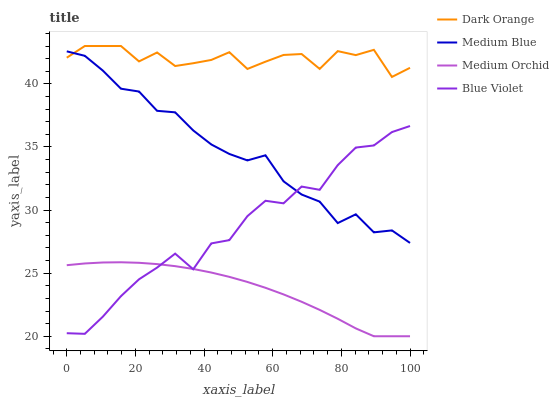Does Medium Blue have the minimum area under the curve?
Answer yes or no. No. Does Medium Blue have the maximum area under the curve?
Answer yes or no. No. Is Medium Blue the smoothest?
Answer yes or no. No. Is Medium Blue the roughest?
Answer yes or no. No. Does Medium Blue have the lowest value?
Answer yes or no. No. Does Medium Blue have the highest value?
Answer yes or no. No. Is Blue Violet less than Dark Orange?
Answer yes or no. Yes. Is Medium Blue greater than Medium Orchid?
Answer yes or no. Yes. Does Blue Violet intersect Dark Orange?
Answer yes or no. No. 